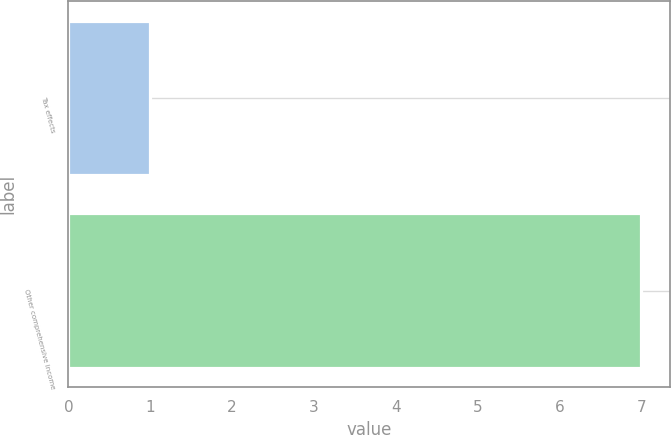Convert chart. <chart><loc_0><loc_0><loc_500><loc_500><bar_chart><fcel>Tax effects<fcel>Other comprehensive income<nl><fcel>1<fcel>7<nl></chart> 